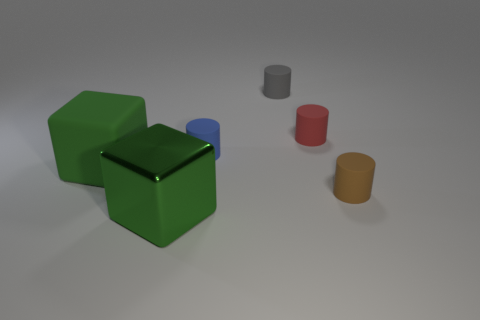Subtract all blocks. How many objects are left? 4 Add 1 tiny blue things. How many objects exist? 7 Subtract all brown cylinders. How many cylinders are left? 3 Subtract all small brown cylinders. How many cylinders are left? 3 Subtract 0 yellow cylinders. How many objects are left? 6 Subtract 4 cylinders. How many cylinders are left? 0 Subtract all green cylinders. Subtract all yellow balls. How many cylinders are left? 4 Subtract all green cylinders. How many red cubes are left? 0 Subtract all big gray matte things. Subtract all rubber things. How many objects are left? 1 Add 5 tiny brown matte cylinders. How many tiny brown matte cylinders are left? 6 